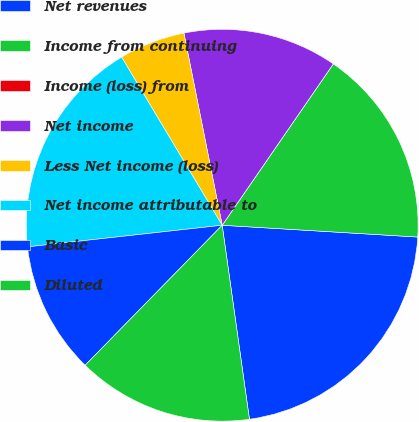<chart> <loc_0><loc_0><loc_500><loc_500><pie_chart><fcel>Net revenues<fcel>Income from continuing<fcel>Income (loss) from<fcel>Net income<fcel>Less Net income (loss)<fcel>Net income attributable to<fcel>Basic<fcel>Diluted<nl><fcel>21.82%<fcel>16.36%<fcel>0.0%<fcel>12.73%<fcel>5.45%<fcel>18.18%<fcel>10.91%<fcel>14.55%<nl></chart> 